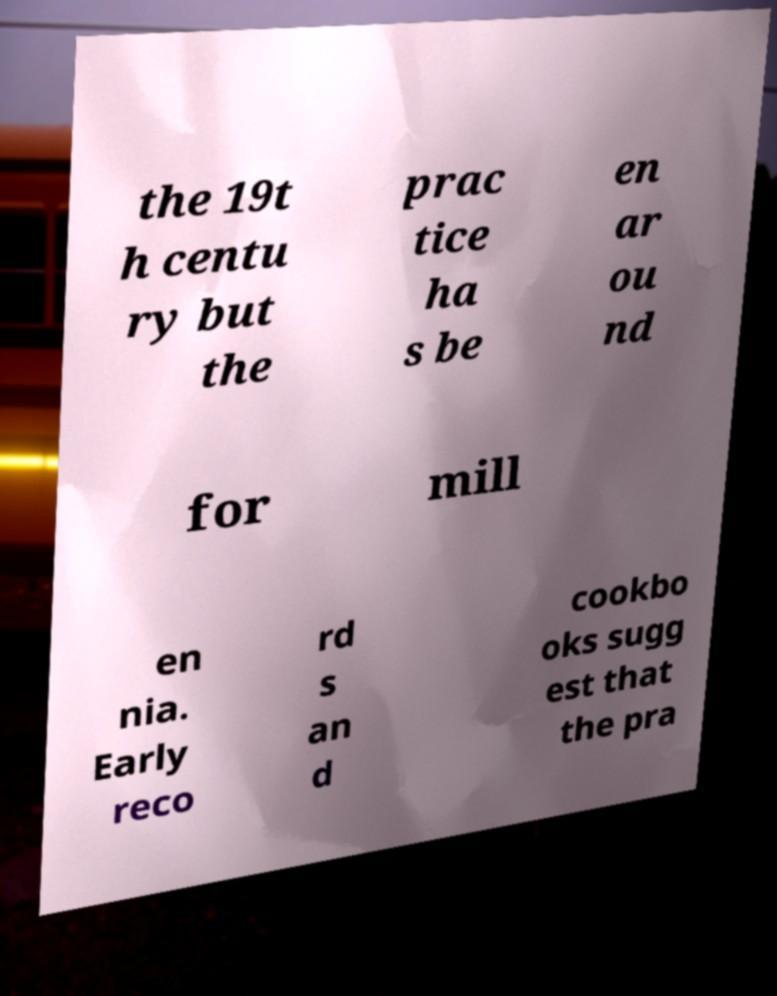For documentation purposes, I need the text within this image transcribed. Could you provide that? the 19t h centu ry but the prac tice ha s be en ar ou nd for mill en nia. Early reco rd s an d cookbo oks sugg est that the pra 